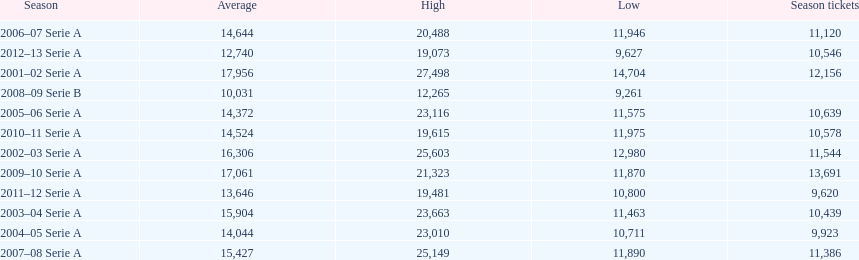How many seasons at the stadio ennio tardini had 11,000 or more season tickets? 5. 